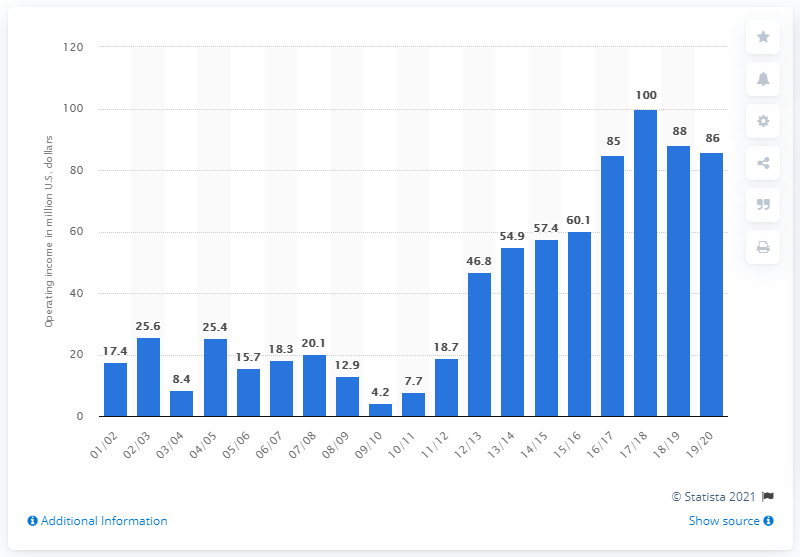Highlight a few significant elements in this photo. The operating income of the Boston Celtics in the 2019/20 season was $86 million. 